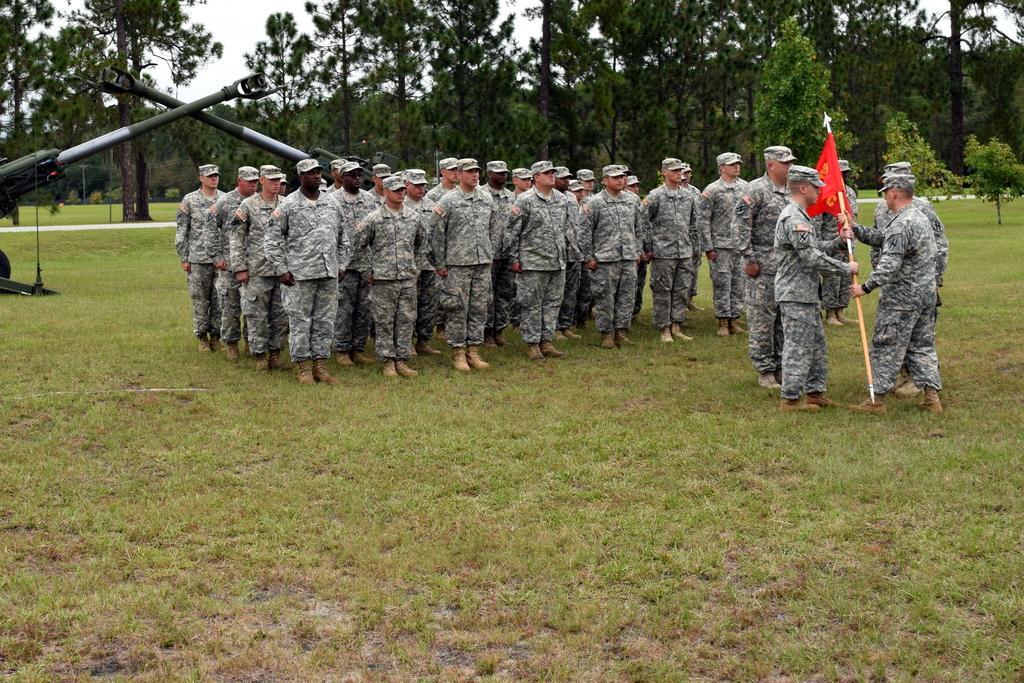Describe this image in one or two sentences. In this image in the center there are a group of people who are standing, and some of them are holding pole and flag. And on the left side there are some poles, it seems that this is some vehicle. And at the bottom there is grass, and in the background there are trees and sky. 